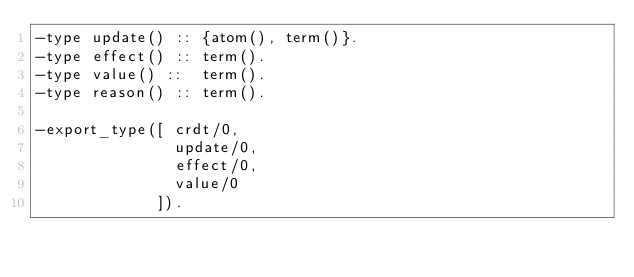Convert code to text. <code><loc_0><loc_0><loc_500><loc_500><_Erlang_>-type update() :: {atom(), term()}.
-type effect() :: term().
-type value() ::  term().
-type reason() :: term().

-export_type([ crdt/0,
               update/0,
               effect/0,
               value/0
             ]).
</code> 